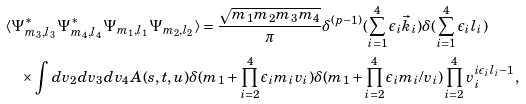<formula> <loc_0><loc_0><loc_500><loc_500>& \langle \Psi ^ { * } _ { m _ { 3 } , l _ { 3 } } \Psi ^ { * } _ { m _ { 4 } , l _ { 4 } } \Psi _ { m _ { 1 } , l _ { 1 } } \Psi _ { m _ { 2 } , l _ { 2 } } \rangle = \frac { \sqrt { m _ { 1 } m _ { 2 } m _ { 3 } m _ { 4 } } } { \pi } \delta ^ { ( p - 1 ) } ( \sum _ { i = 1 } ^ { 4 } \epsilon _ { i } \vec { k } _ { i } ) \delta ( \sum _ { i = 1 } ^ { 4 } \epsilon _ { i } l _ { i } ) \\ & \quad \times \int d v _ { 2 } d v _ { 3 } d v _ { 4 } A ( s , t , u ) \delta ( m _ { 1 } + \prod _ { i = 2 } ^ { 4 } \epsilon _ { i } m _ { i } v _ { i } ) \delta ( m _ { 1 } + \prod _ { i = 2 } ^ { 4 } \epsilon _ { i } m _ { i } / v _ { i } ) \prod _ { i = 2 } ^ { 4 } v _ { i } ^ { i \epsilon _ { i } l _ { i } - 1 } ,</formula> 